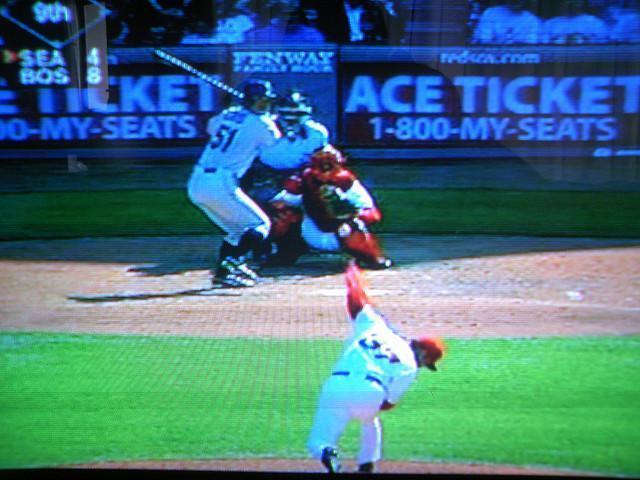How many people are in the photo?
Give a very brief answer. 5. How many of the kites are shaped like an iguana?
Give a very brief answer. 0. 